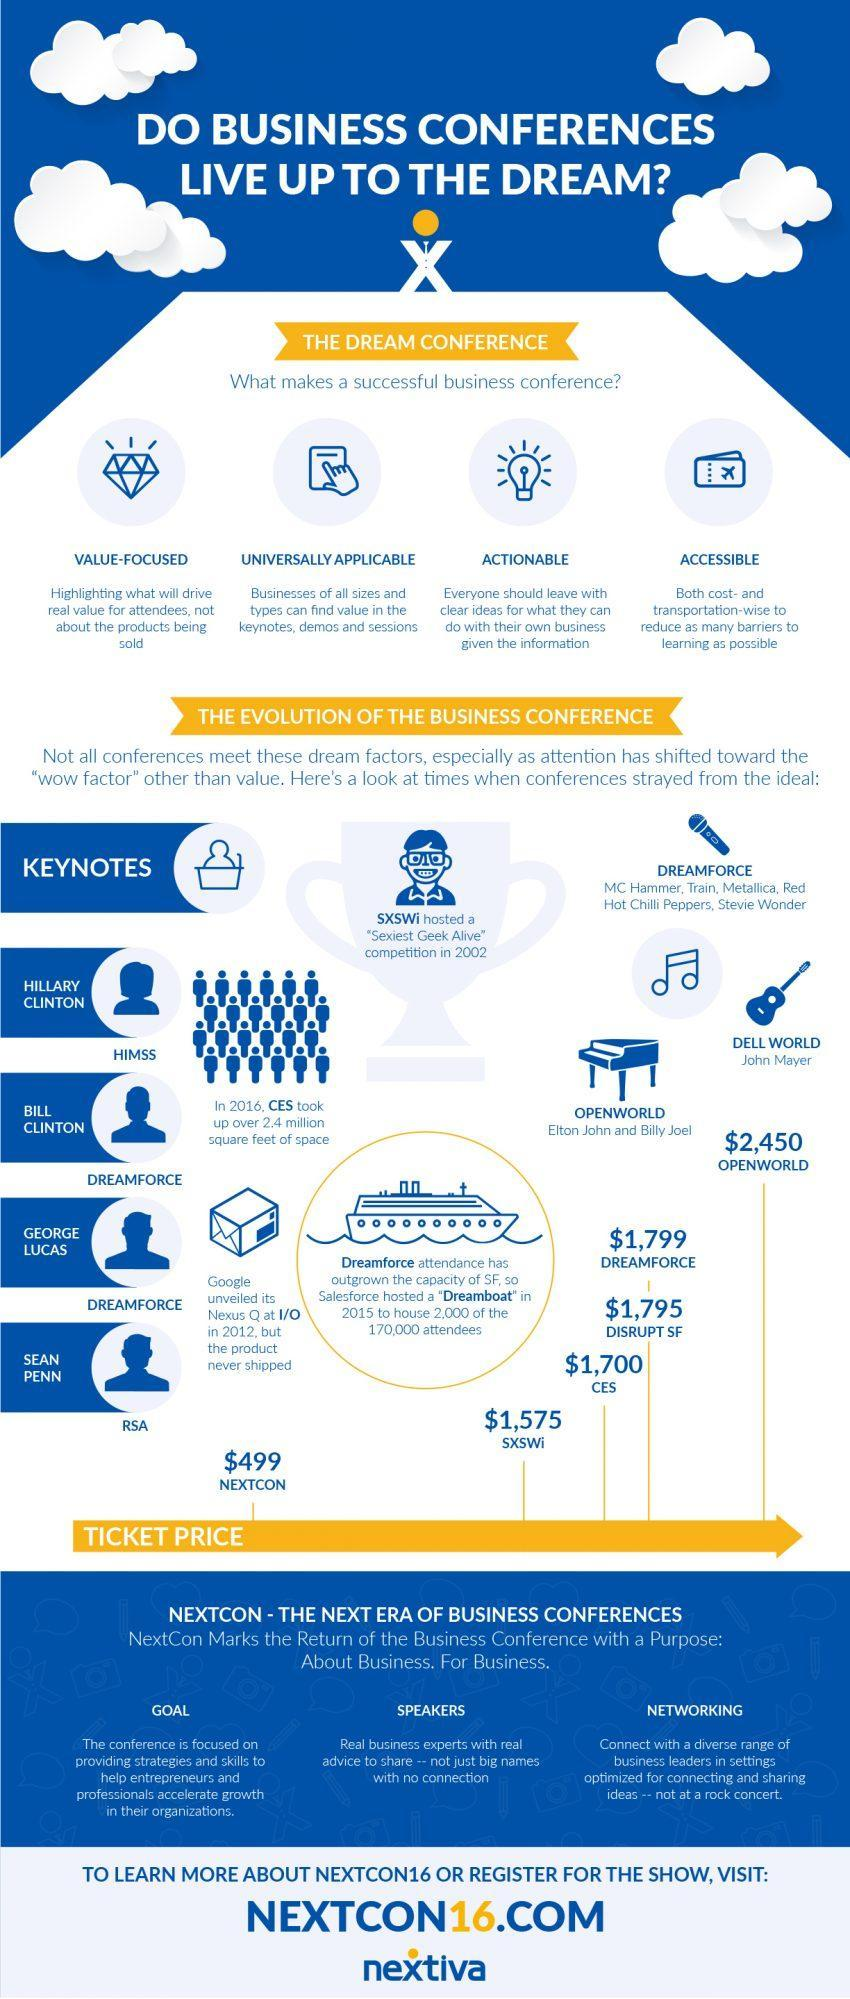Which product of google was never shipped after its unveiling
Answer the question with a short phrase. Nexus Q where were 2,000 of the 170,000 attendees housed dreamboat what was the ticket price for Dreamforce $ 1,799 How many dollars was dreamforce ticket price higher than disrupt SF 4 which ticket price is lower than SXSWi $499 Who all performed at Dreamforce MC Hammer, Train, Metallica, Red Hot Chilli Peppers, Stevie Wonder how many points to be noted to make a successful business conference 4 